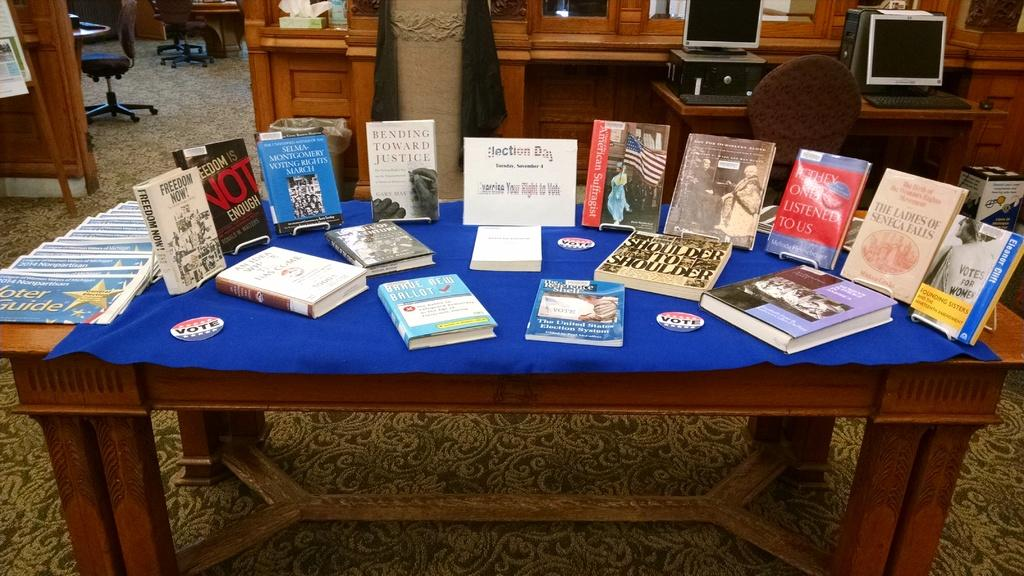What is the main piece of furniture in the image? There is a table in the image. What is on top of the table? There is a blue mat and books on the table. What can be seen behind the table? There are desks behind the table. What is on the desks? There are systems on the desks. What type of lamp is present on the table in the image? There is no lamp present on the table in the image. 